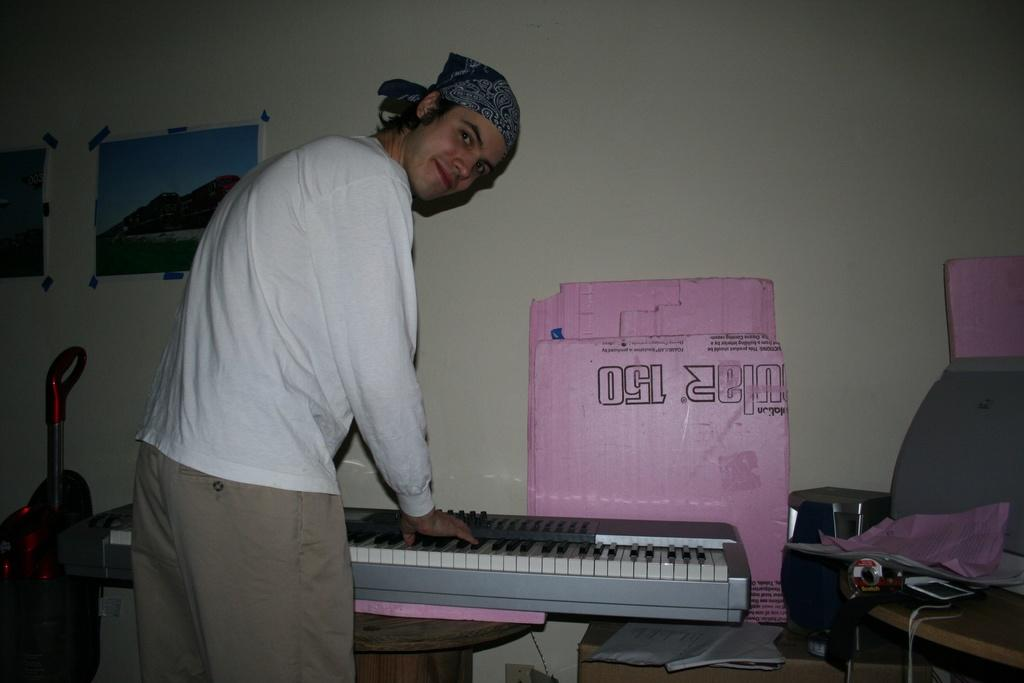What is the man in the image doing? The man is standing in the image and smiling. What can be seen in the background of the image? There is a piano, a cardboard, a wall, and a frame attached to the wall in the background of the image. Can you describe the man's expression in the image? The man is smiling in the image. What is the purpose of the frame in the background of the image? The frame is attached to the wall in the background of the image, possibly to hold a picture or artwork. What type of scarecrow is standing next to the man in the image? There is no scarecrow present in the image; it features a man standing and smiling with various objects in the background. 